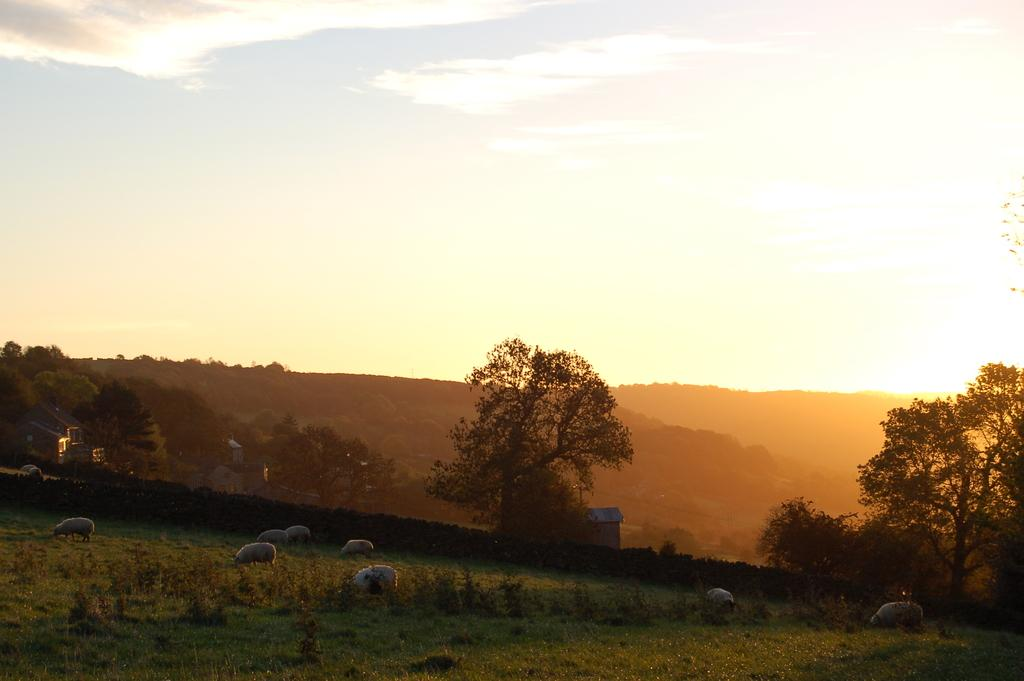What is located at the bottom of the image? There are trees, sheeps, plants, and grass at the bottom of the image. What can be seen in the background of the image? There are buildings, trees, hills, sky, and clouds visible in the background of the image. What type of lace can be seen on the sheeps in the image? There is no lace present on the sheeps in the image. What is the size of the sock that the trees are wearing in the image? There are no socks present on the trees in the image. 